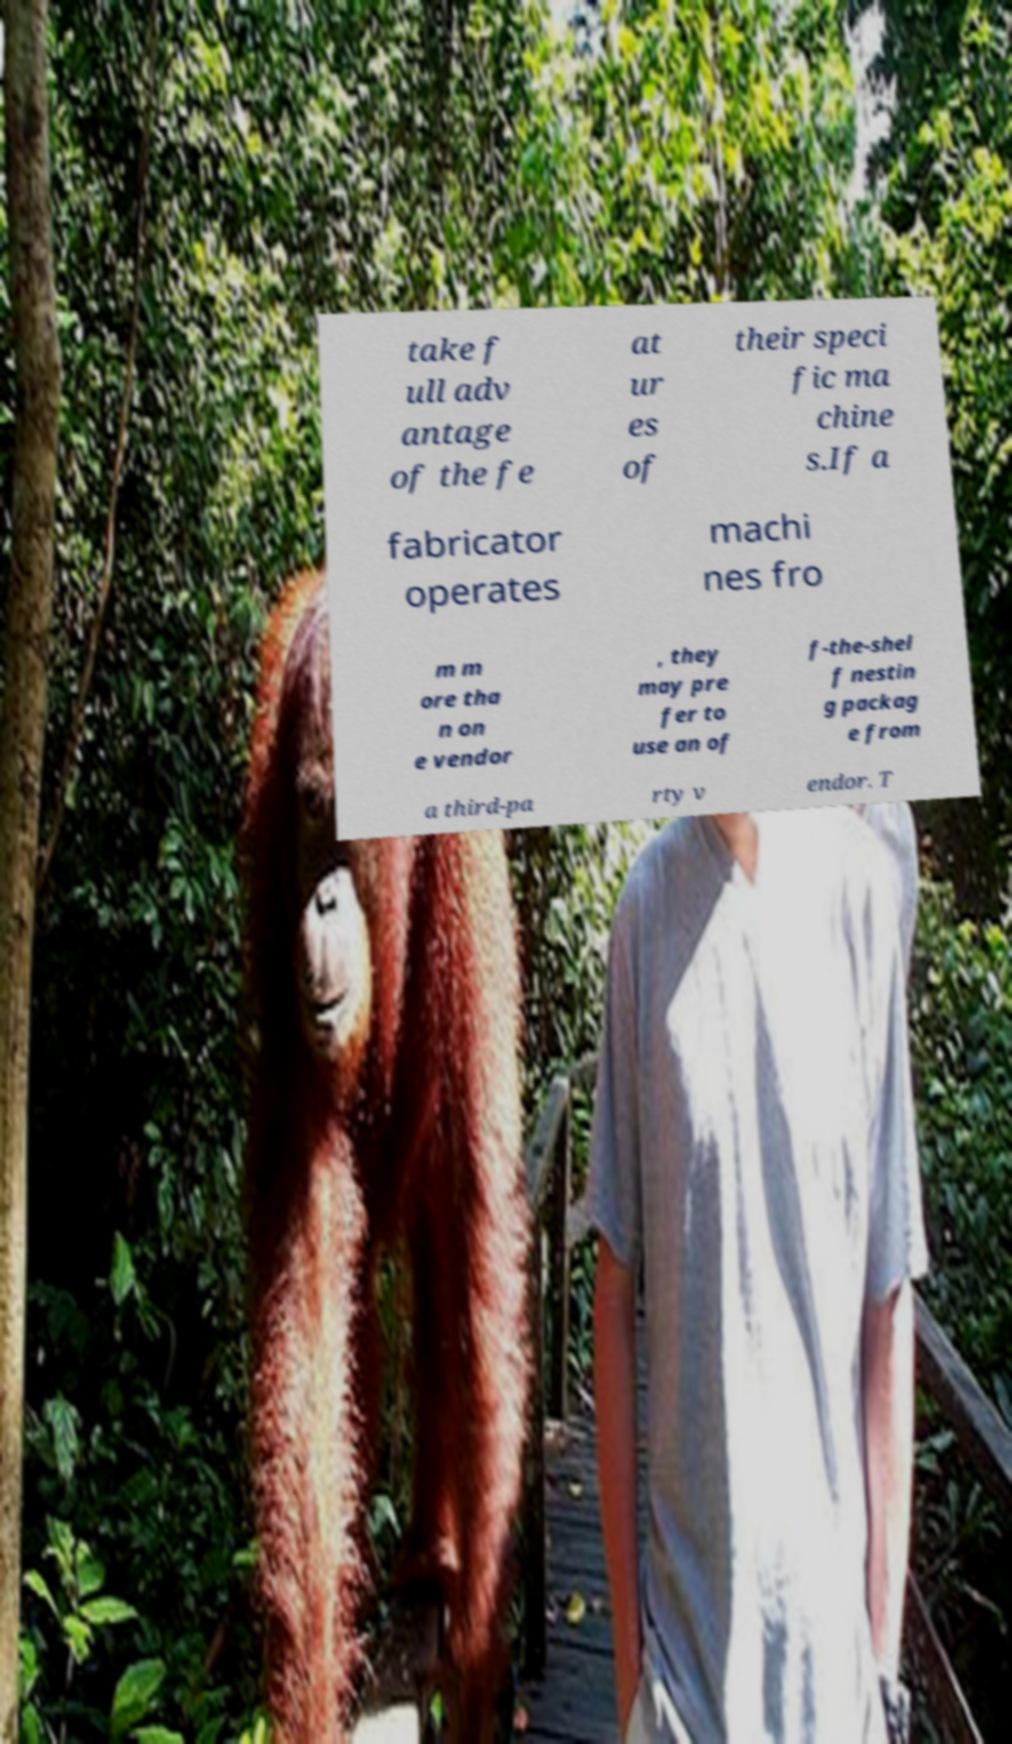Can you read and provide the text displayed in the image?This photo seems to have some interesting text. Can you extract and type it out for me? take f ull adv antage of the fe at ur es of their speci fic ma chine s.If a fabricator operates machi nes fro m m ore tha n on e vendor , they may pre fer to use an of f-the-shel f nestin g packag e from a third-pa rty v endor. T 